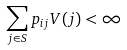Convert formula to latex. <formula><loc_0><loc_0><loc_500><loc_500>\sum _ { j \in S } p _ { i j } V ( j ) < \infty</formula> 